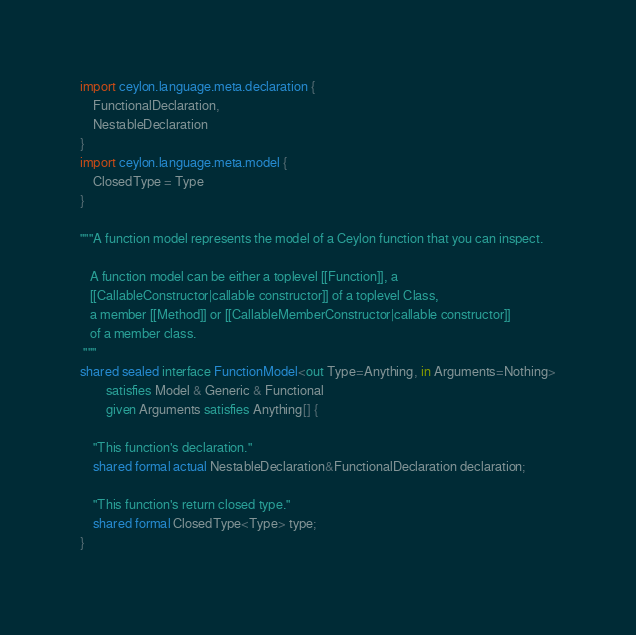Convert code to text. <code><loc_0><loc_0><loc_500><loc_500><_Ceylon_>import ceylon.language.meta.declaration {
    FunctionalDeclaration,
    NestableDeclaration
}
import ceylon.language.meta.model {
    ClosedType = Type
}

"""A function model represents the model of a Ceylon function that you can inspect.
   
   A function model can be either a toplevel [[Function]], a 
   [[CallableConstructor|callable constructor]] of a toplevel Class,
   a member [[Method]] or [[CallableMemberConstructor|callable constructor]]
   of a member class.
 """
shared sealed interface FunctionModel<out Type=Anything, in Arguments=Nothing>
        satisfies Model & Generic & Functional
        given Arguments satisfies Anything[] {

    "This function's declaration."
    shared formal actual NestableDeclaration&FunctionalDeclaration declaration;

    "This function's return closed type."
    shared formal ClosedType<Type> type;
}
</code> 